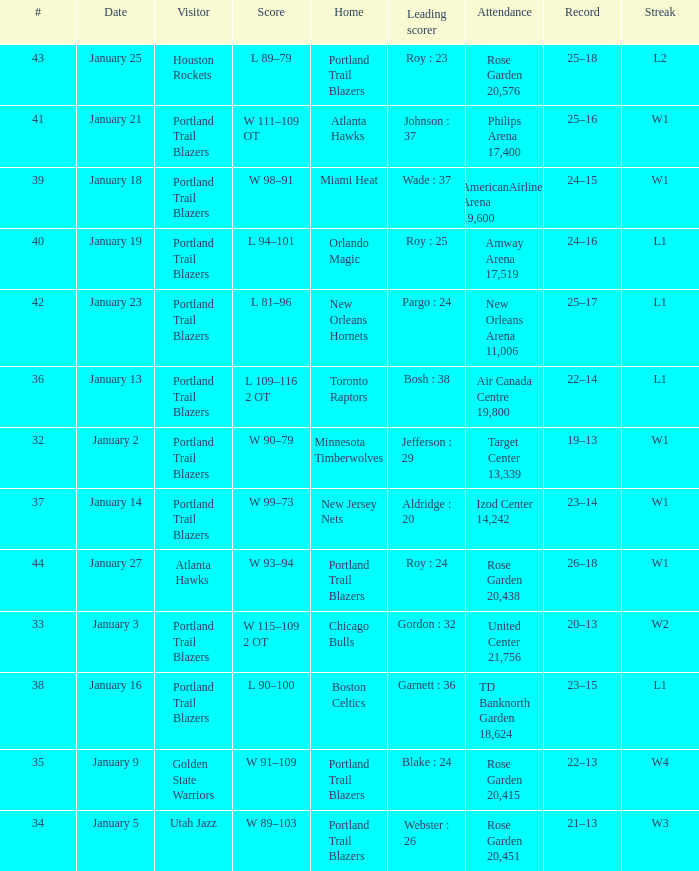What is the total number of dates where the scorer is gordon : 32 1.0. 